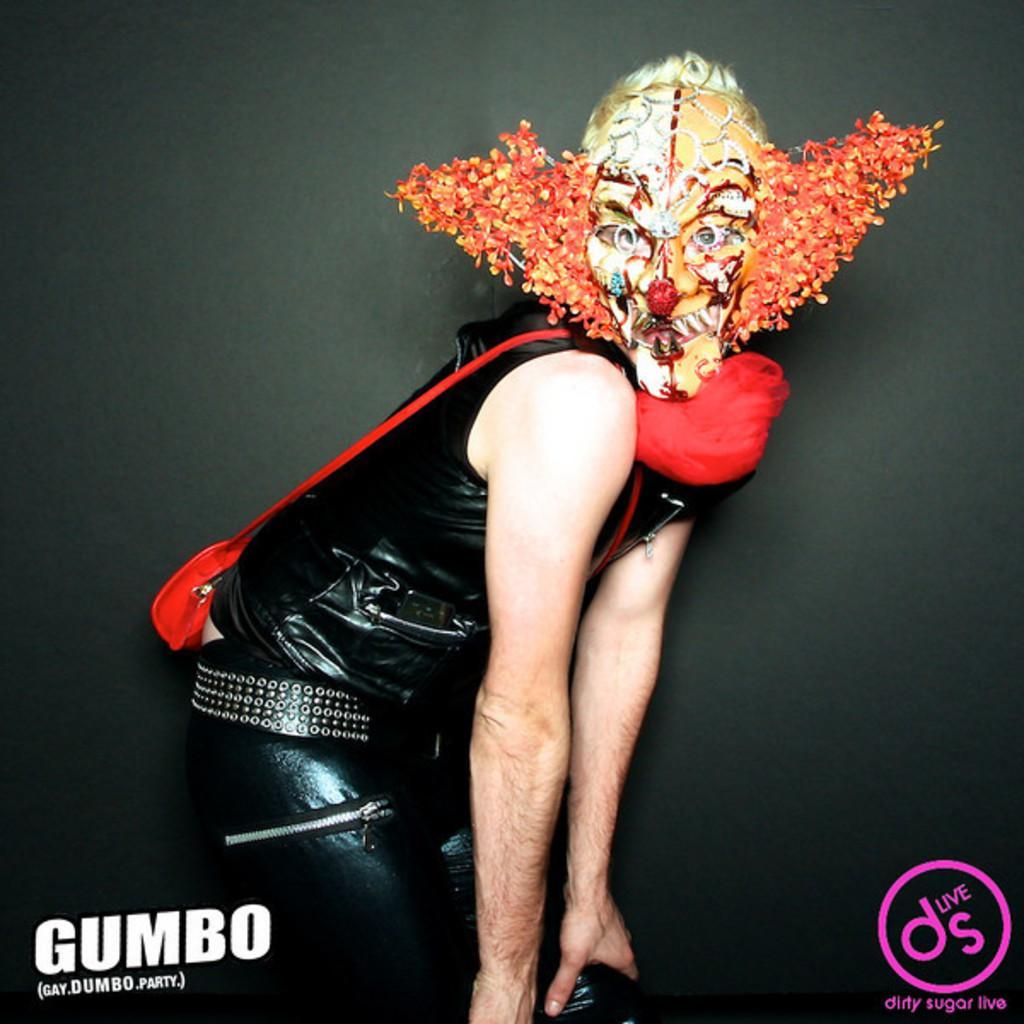In one or two sentences, can you explain what this image depicts? A person is present wearing a mask. He is wearing a black dress and a red sling bag. 